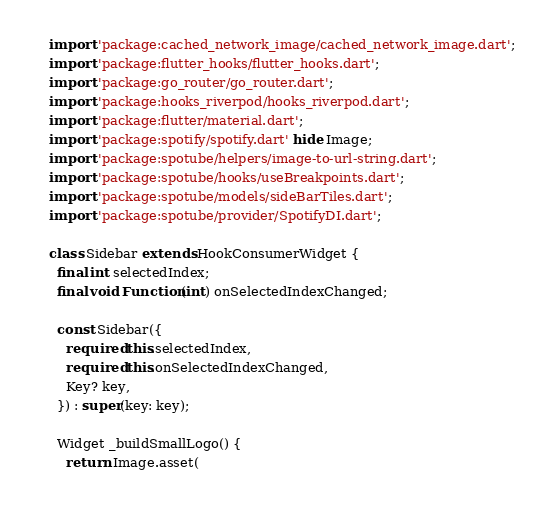<code> <loc_0><loc_0><loc_500><loc_500><_Dart_>import 'package:cached_network_image/cached_network_image.dart';
import 'package:flutter_hooks/flutter_hooks.dart';
import 'package:go_router/go_router.dart';
import 'package:hooks_riverpod/hooks_riverpod.dart';
import 'package:flutter/material.dart';
import 'package:spotify/spotify.dart' hide Image;
import 'package:spotube/helpers/image-to-url-string.dart';
import 'package:spotube/hooks/useBreakpoints.dart';
import 'package:spotube/models/sideBarTiles.dart';
import 'package:spotube/provider/SpotifyDI.dart';

class Sidebar extends HookConsumerWidget {
  final int selectedIndex;
  final void Function(int) onSelectedIndexChanged;

  const Sidebar({
    required this.selectedIndex,
    required this.onSelectedIndexChanged,
    Key? key,
  }) : super(key: key);

  Widget _buildSmallLogo() {
    return Image.asset(</code> 